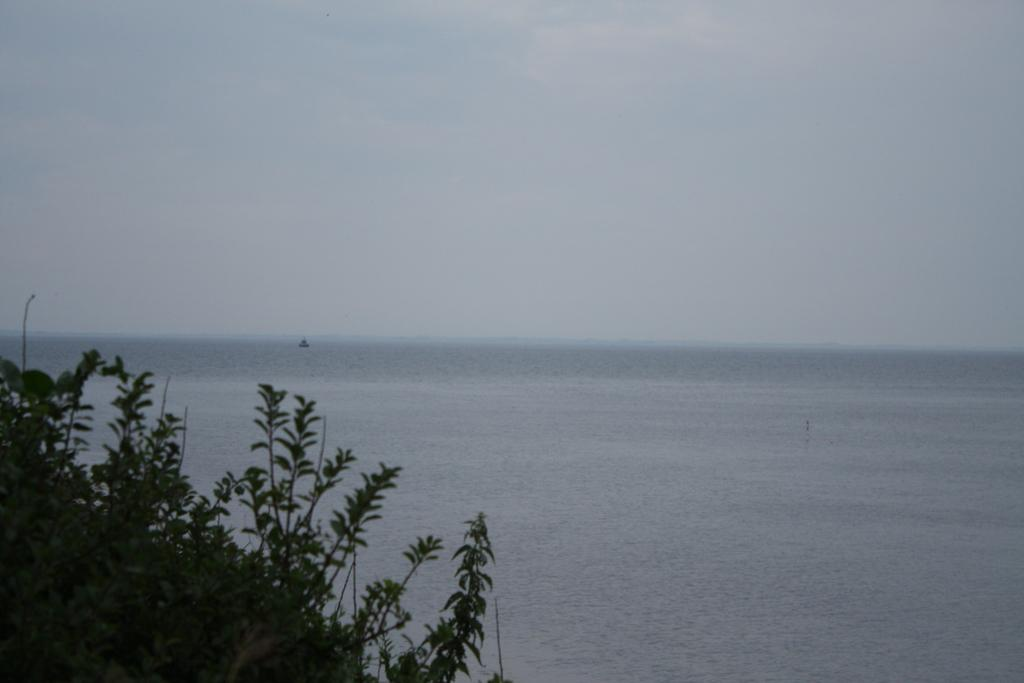What type of vegetation is on the left side of the image? There are plants on the left side of the image. What can be seen on the right side of the image? There is water on the right side of the image. What is visible in the sky in the background of the image? There are clouds in the sky in the background of the image. What type of apparatus is being used to pull the clouds in the image? There is no apparatus or action of pulling the clouds in the image; they are simply visible in the sky. Can you see a spade being used in the water on the right side of the image? There is no spade or any other tool visible in the water on the right side of the image. 